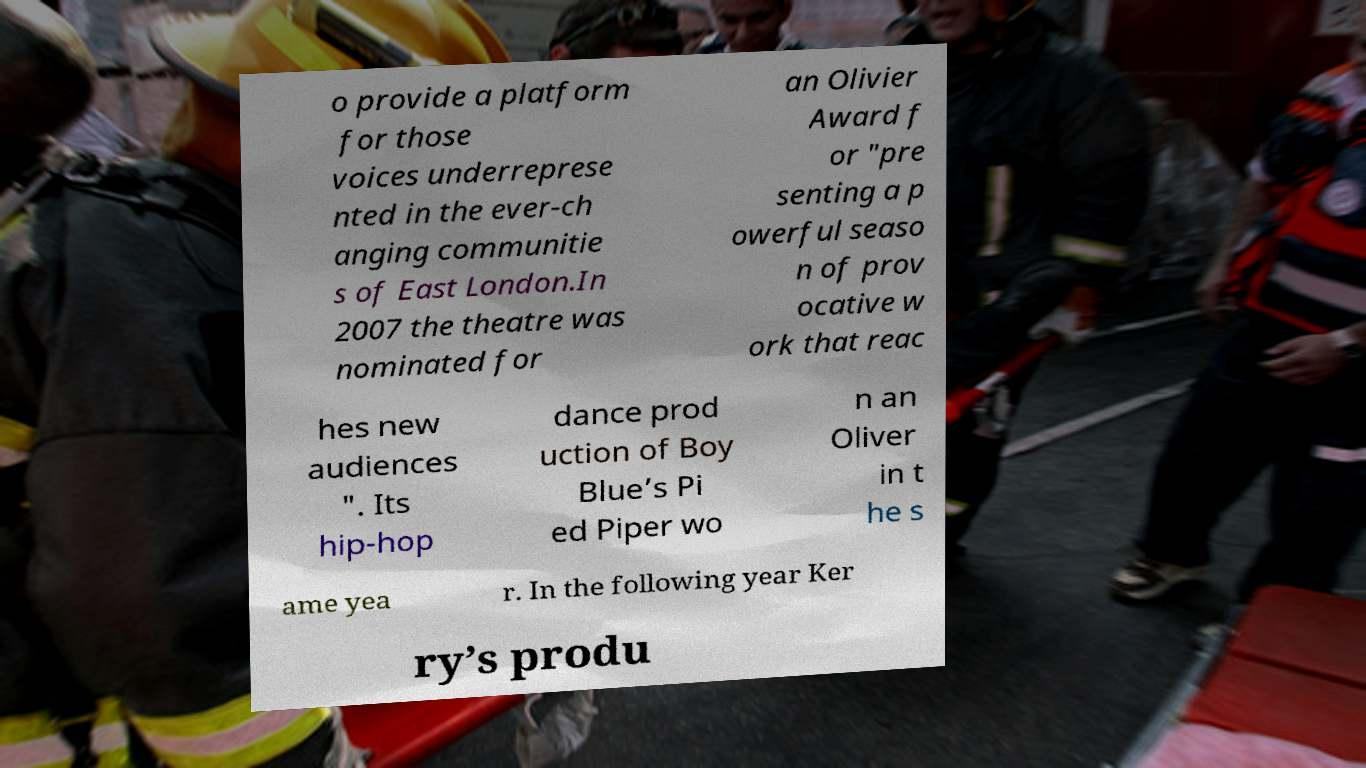What messages or text are displayed in this image? I need them in a readable, typed format. o provide a platform for those voices underreprese nted in the ever-ch anging communitie s of East London.In 2007 the theatre was nominated for an Olivier Award f or "pre senting a p owerful seaso n of prov ocative w ork that reac hes new audiences ". Its hip-hop dance prod uction of Boy Blue’s Pi ed Piper wo n an Oliver in t he s ame yea r. In the following year Ker ry’s produ 